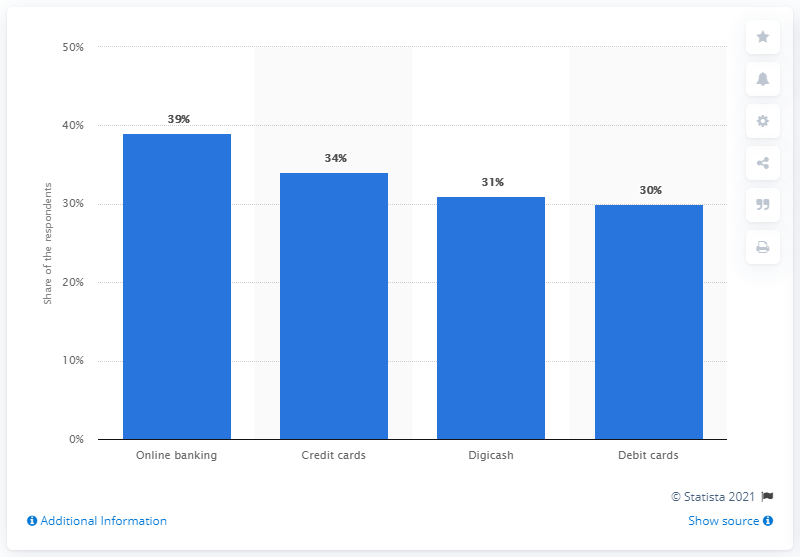List a handful of essential elements in this visual. According to sources, Digicash is the third most popular payment system used in Luxembourg. According to the responses, 34% of the respondents indicated that online banking was their preferred method of payment. 